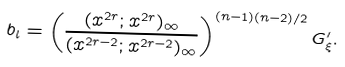Convert formula to latex. <formula><loc_0><loc_0><loc_500><loc_500>b _ { l } = \left ( \frac { ( x ^ { 2 r } ; x ^ { 2 r } ) _ { \infty } } { ( x ^ { 2 r - 2 } ; x ^ { 2 r - 2 } ) _ { \infty } } \right ) ^ { ( n - 1 ) ( n - 2 ) / 2 } G ^ { \prime } _ { \xi } .</formula> 